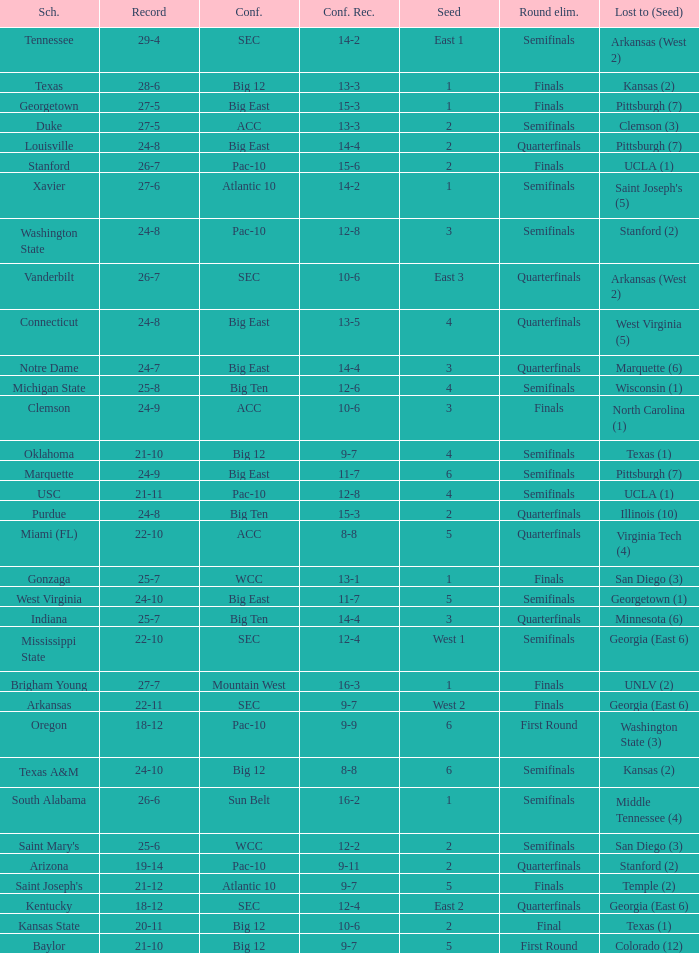Name the conference record where seed is 3 and record is 24-9 10-6. 